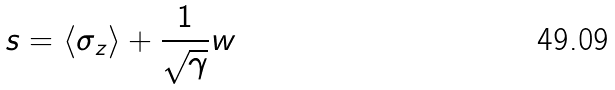<formula> <loc_0><loc_0><loc_500><loc_500>s = \langle \sigma _ { z } \rangle + \frac { 1 } { \sqrt { \gamma } } w</formula> 